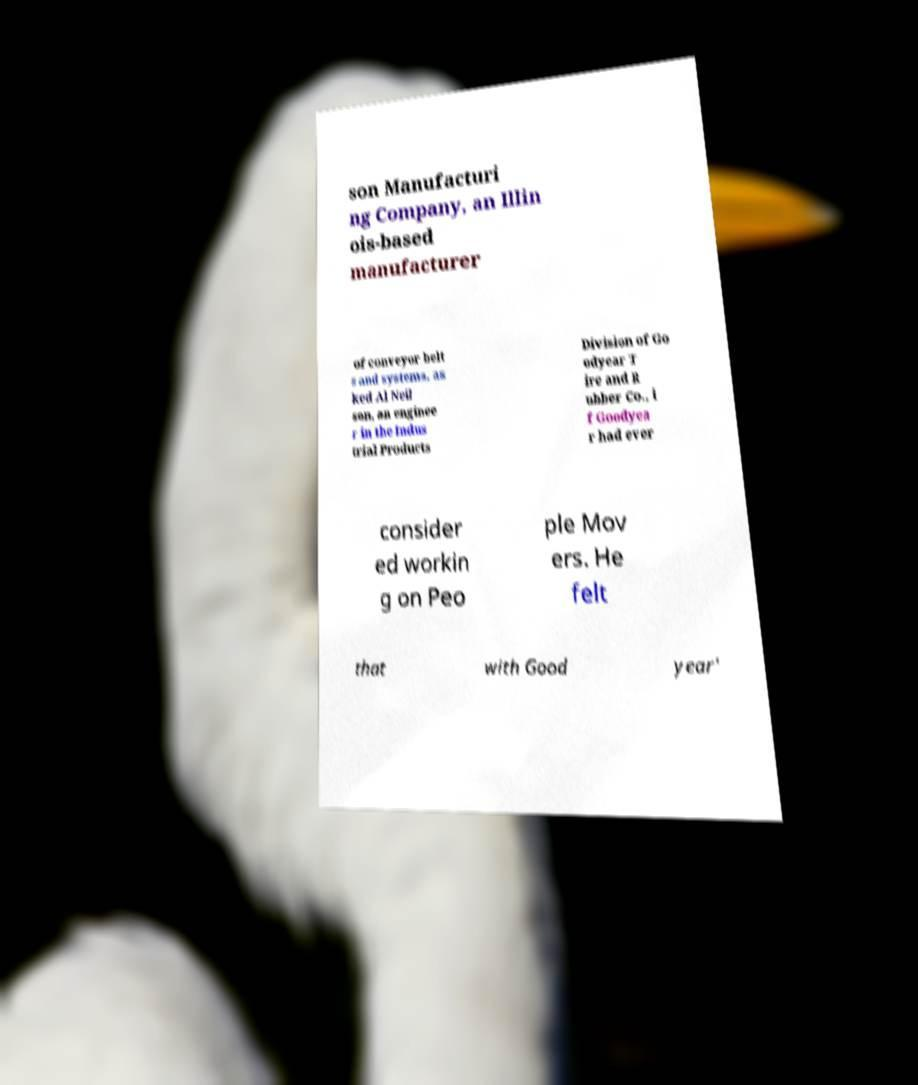Can you read and provide the text displayed in the image?This photo seems to have some interesting text. Can you extract and type it out for me? son Manufacturi ng Company, an Illin ois-based manufacturer of conveyor belt s and systems, as ked Al Neil son, an enginee r in the Indus trial Products Division of Go odyear T ire and R ubber Co., i f Goodyea r had ever consider ed workin g on Peo ple Mov ers. He felt that with Good year' 